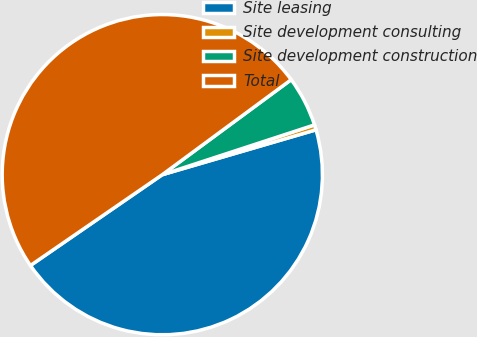Convert chart. <chart><loc_0><loc_0><loc_500><loc_500><pie_chart><fcel>Site leasing<fcel>Site development consulting<fcel>Site development construction<fcel>Total<nl><fcel>44.92%<fcel>0.51%<fcel>5.08%<fcel>49.49%<nl></chart> 